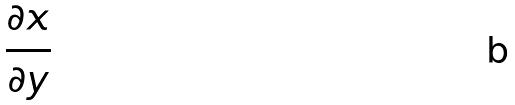<formula> <loc_0><loc_0><loc_500><loc_500>\frac { \partial x } { \partial y }</formula> 